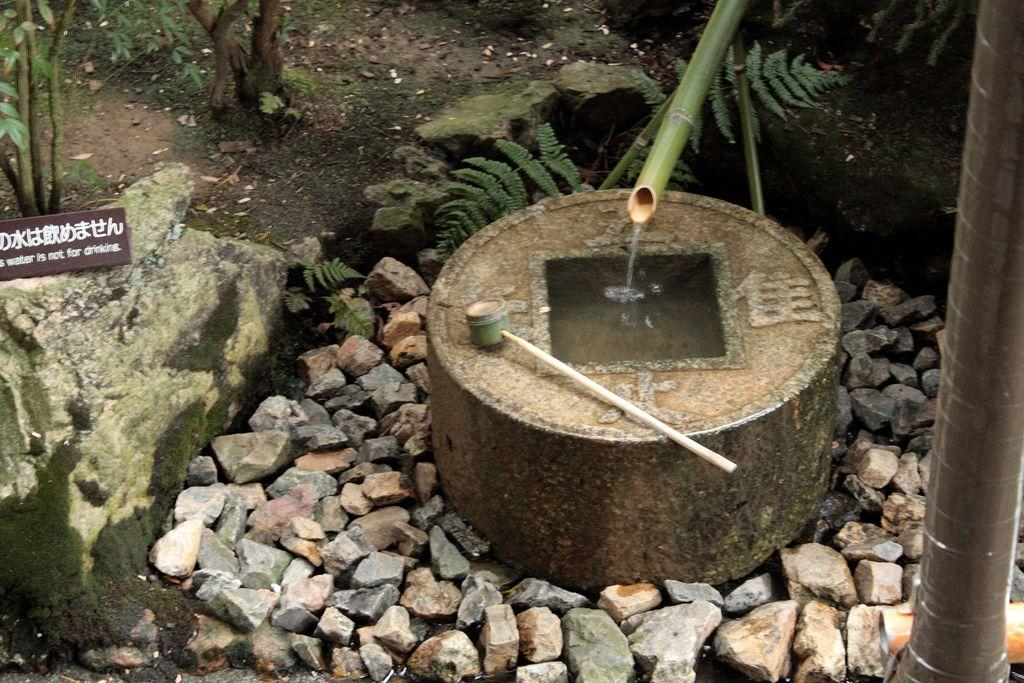What type of tap is in the image? There is a bamboo tap in the image. What is the bamboo tap doing? Water is flowing from the tap. Where does the water flow after leaving the tap? The water flows into a hole in between a cement object. What is around the cement object? There are stones around the cement object. What else can be seen near the cement object? There are plants near the cement object. What type of zinc is present in the image? There is no zinc present in the image. How many roses can be seen growing near the cement object? There are no roses visible in the image; only plants are mentioned. 